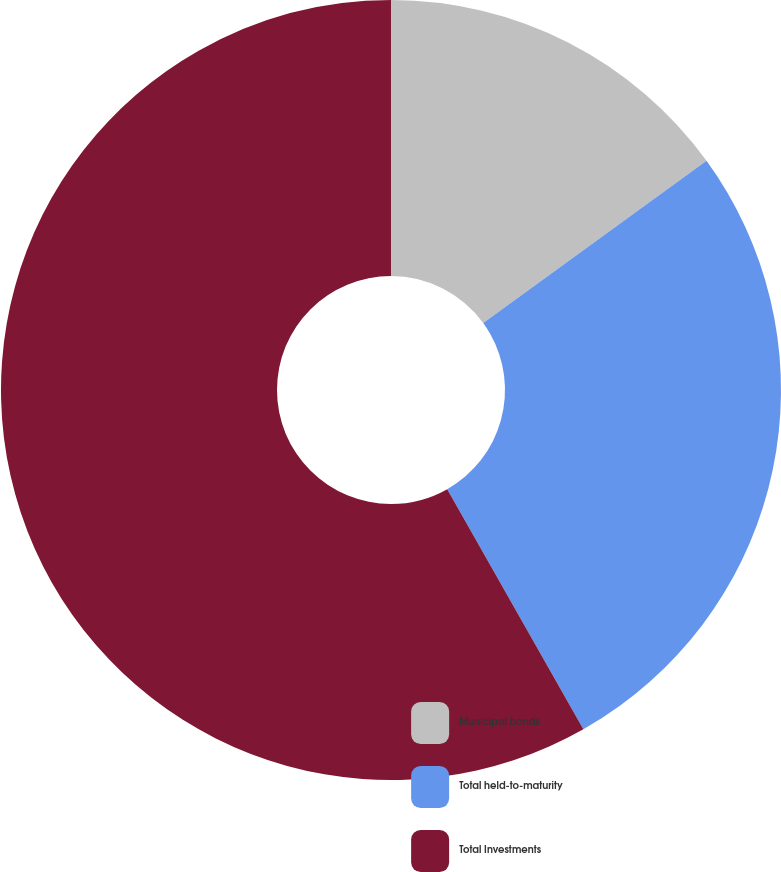Convert chart to OTSL. <chart><loc_0><loc_0><loc_500><loc_500><pie_chart><fcel>Municipal bonds<fcel>Total held-to-maturity<fcel>Total Investments<nl><fcel>15.0%<fcel>26.79%<fcel>58.21%<nl></chart> 